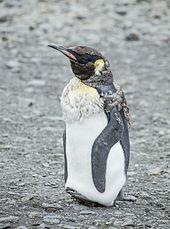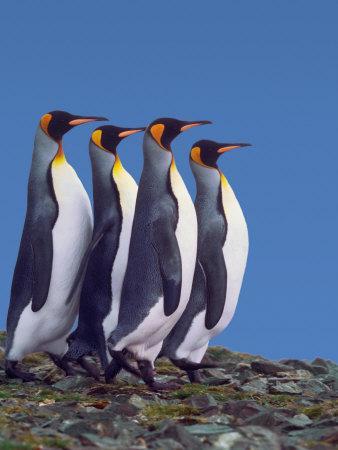The first image is the image on the left, the second image is the image on the right. Evaluate the accuracy of this statement regarding the images: "A single black and white penguin with yellow markings stands alone in the image on the left.". Is it true? Answer yes or no. Yes. 